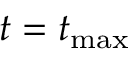<formula> <loc_0><loc_0><loc_500><loc_500>t = t _ { \max }</formula> 